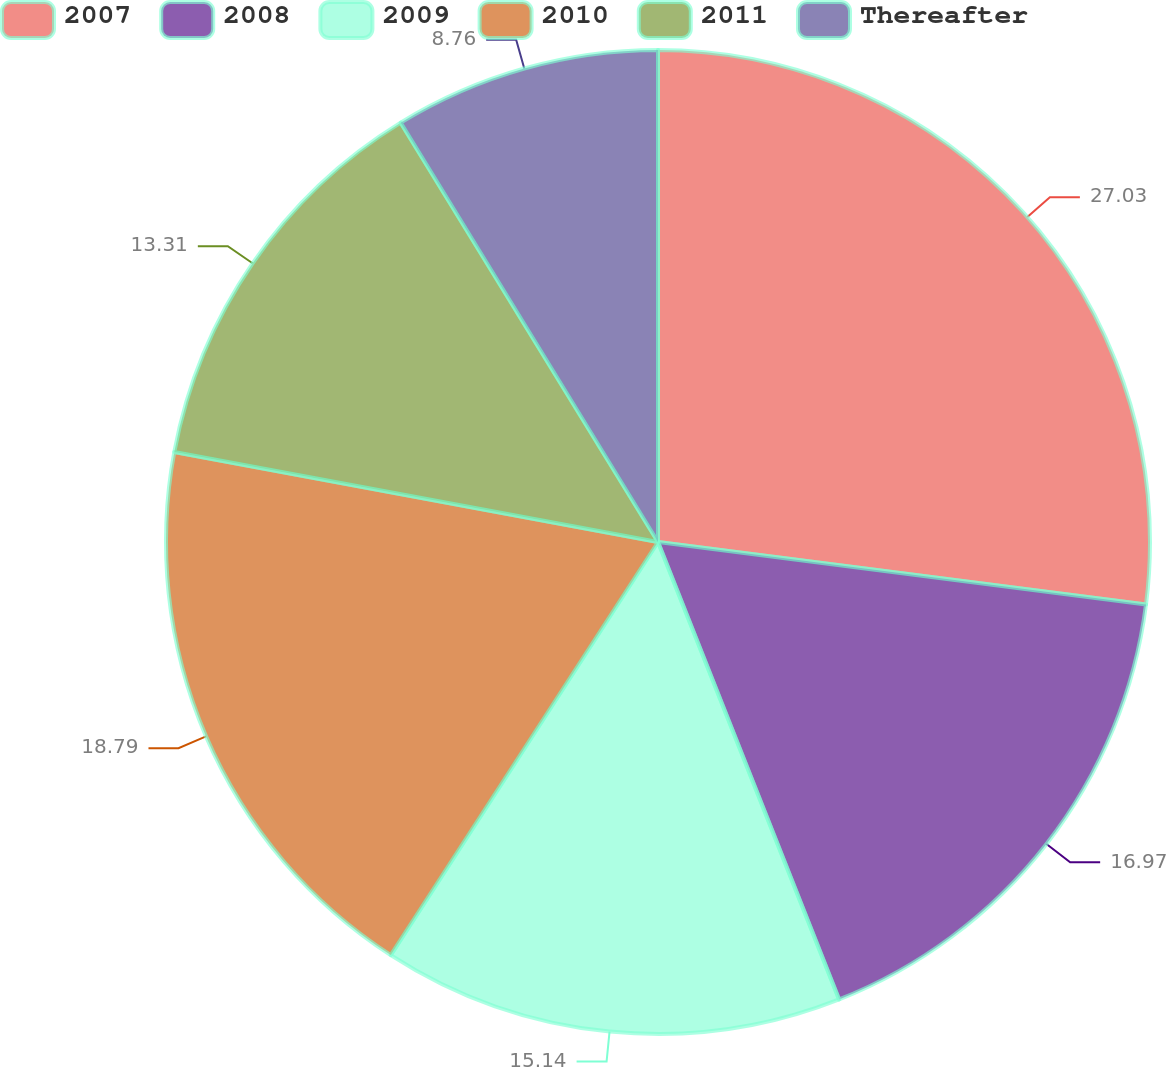<chart> <loc_0><loc_0><loc_500><loc_500><pie_chart><fcel>2007<fcel>2008<fcel>2009<fcel>2010<fcel>2011<fcel>Thereafter<nl><fcel>27.03%<fcel>16.97%<fcel>15.14%<fcel>18.79%<fcel>13.31%<fcel>8.76%<nl></chart> 